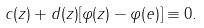<formula> <loc_0><loc_0><loc_500><loc_500>c ( z ) + d ( z ) [ \varphi ( z ) - \varphi ( e ) ] \equiv 0 .</formula> 